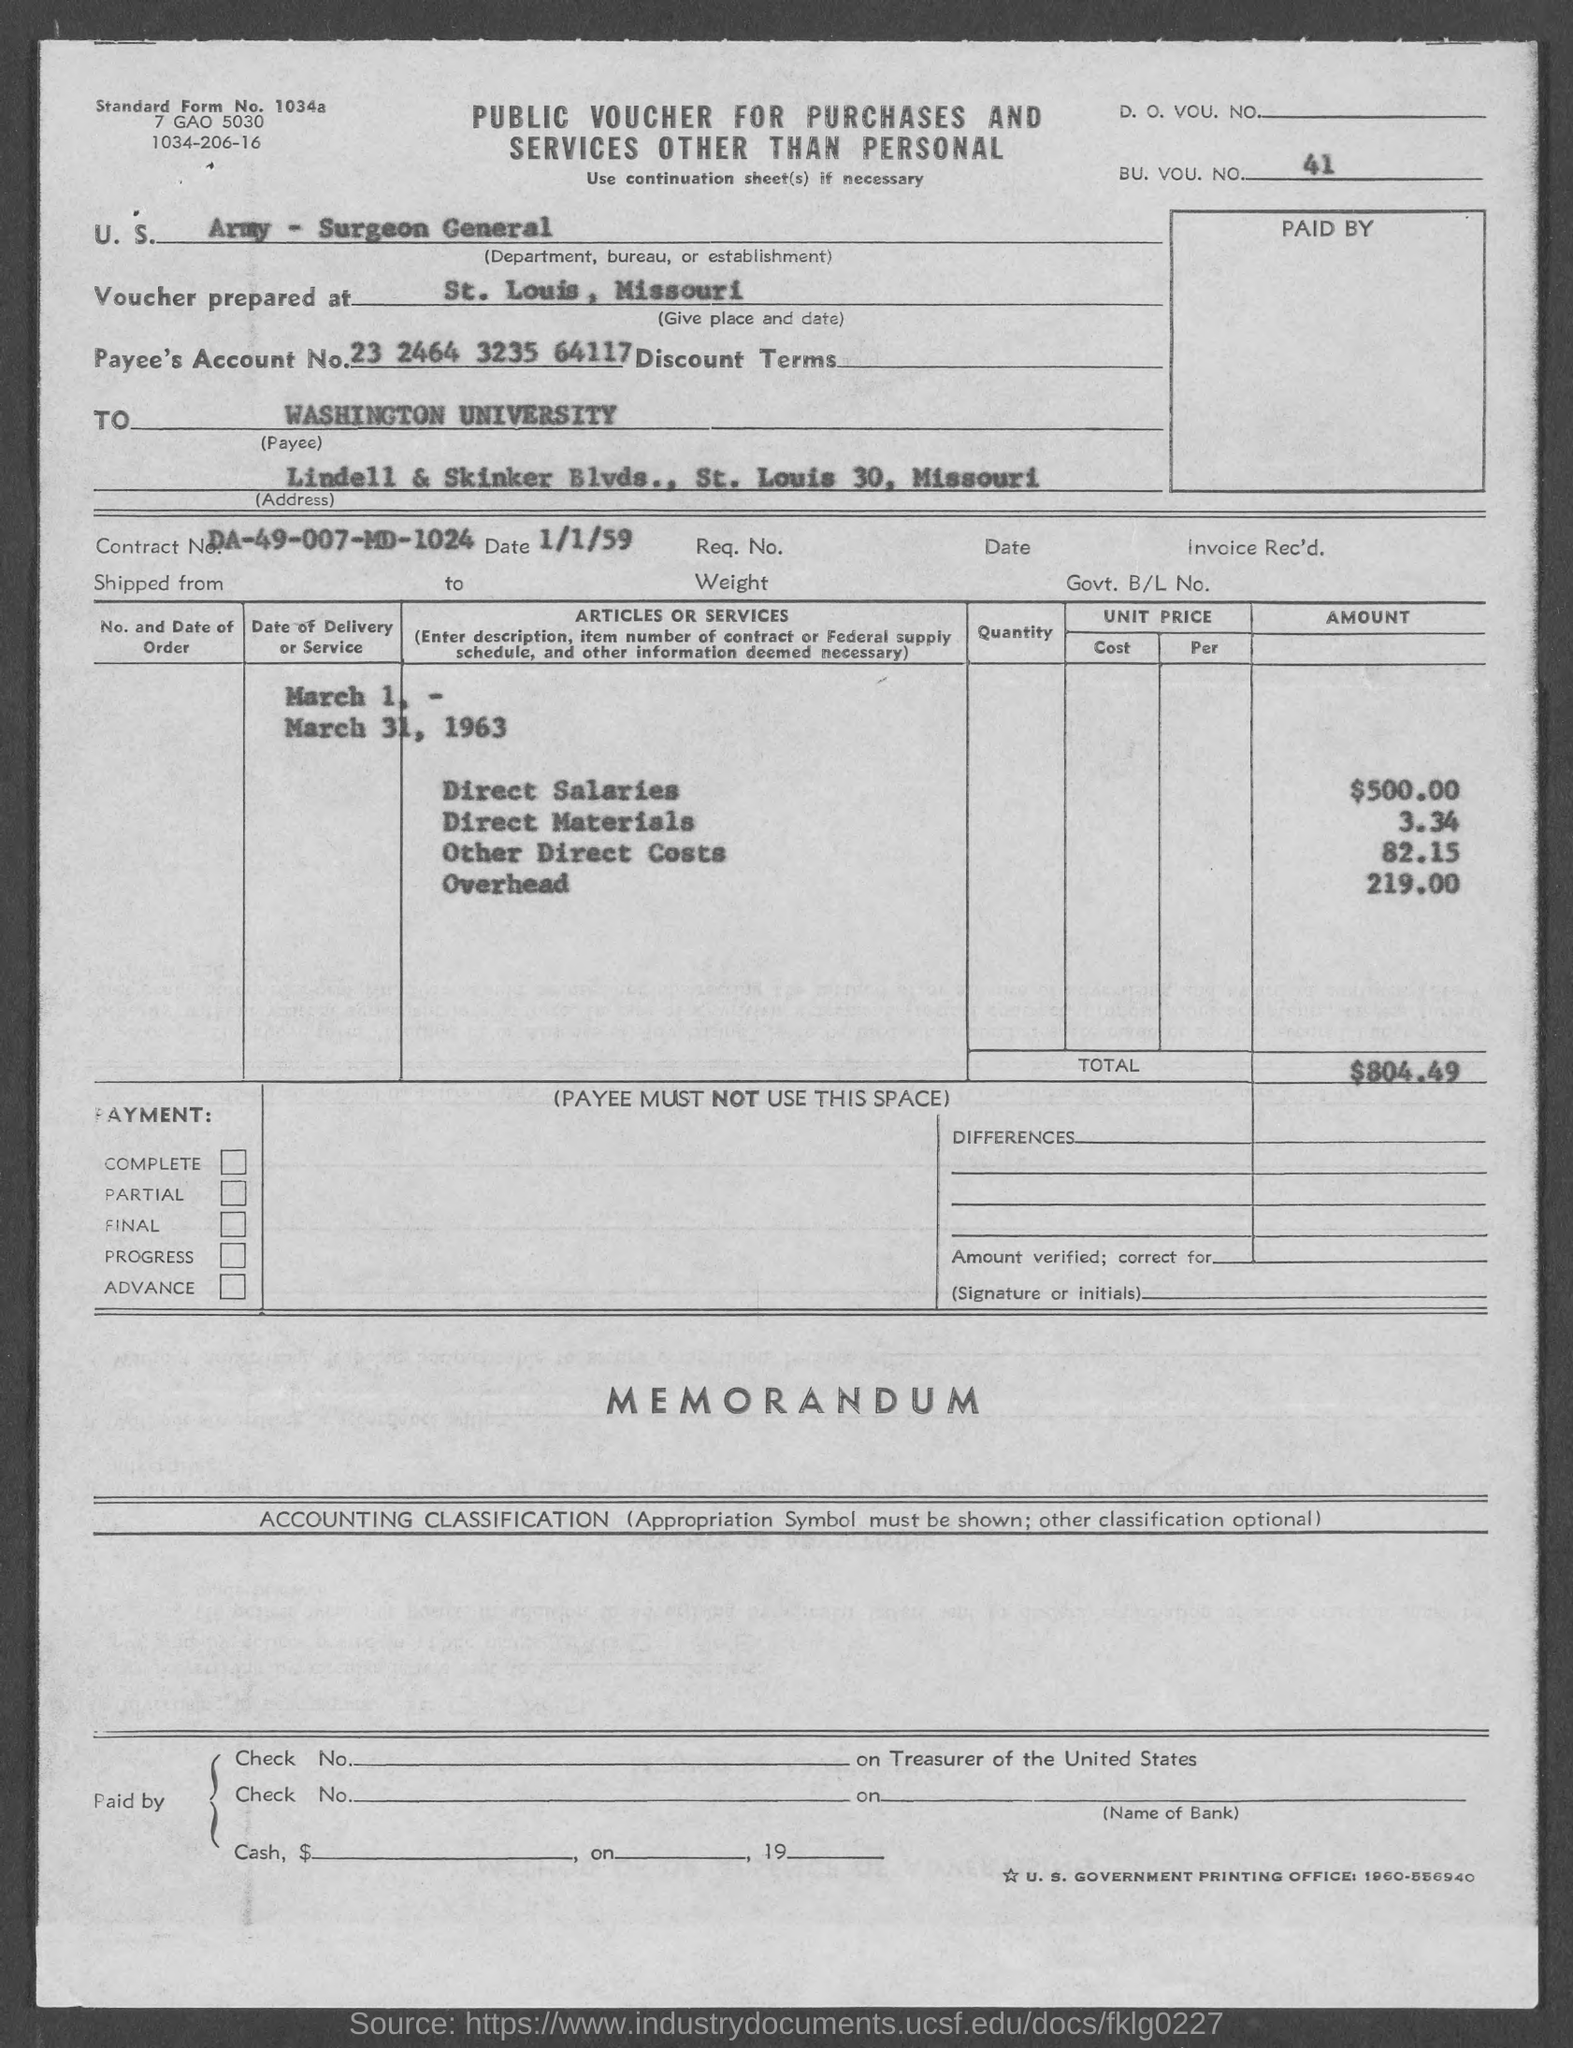Specify some key components in this picture. The voucher was prepared in St. Louis, Missouri. The voucher mentions a BU. VOU. NO. of 41. The standard form number specified in the voucher is Standard Form No. 1034a. The total amount listed in the voucher is $804.49. The Contract No. given in the voucher is DA-49-007-MD-1024. 